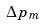<formula> <loc_0><loc_0><loc_500><loc_500>\Delta p _ { m }</formula> 